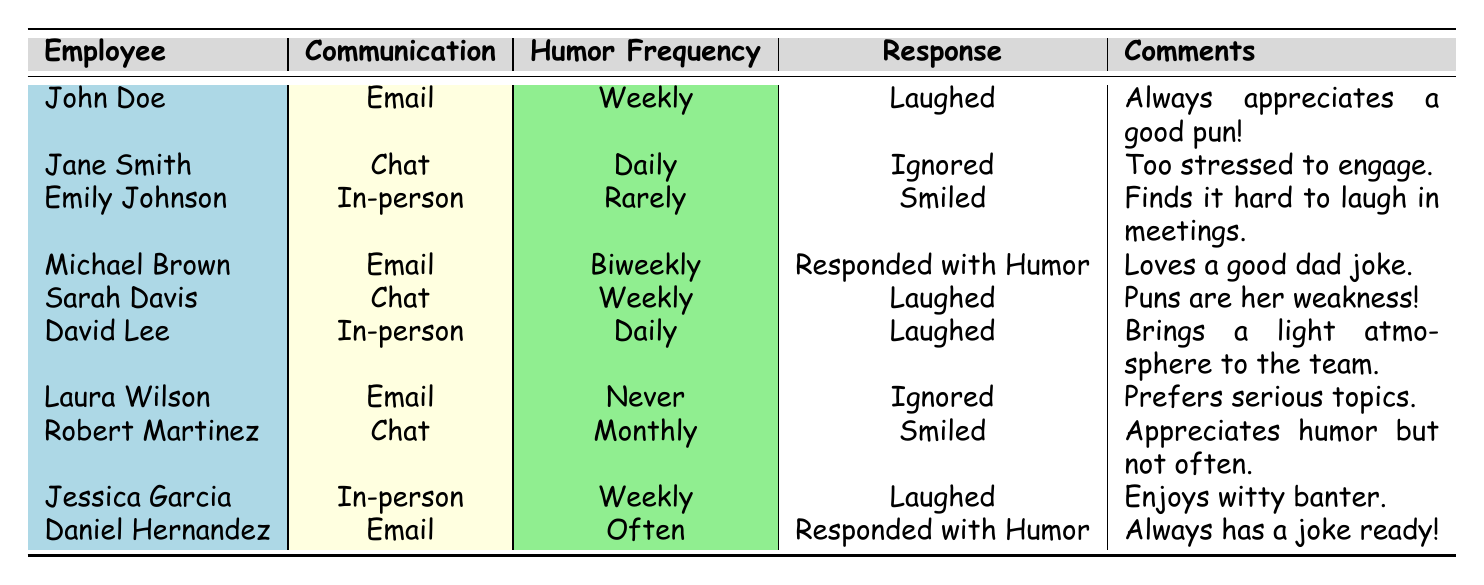What is the response type for John Doe? The table shows that John Doe's response type is "Laughed."
Answer: Laughed How many employees have a humor frequency of "Daily"? There are two employees with a humor frequency of "Daily": Jane Smith and David Lee.
Answer: 2 Which communication type received the most "Laughed" responses? Looking at the response types, "Chat" (Sarah Davis) and "In-person" (David Lee, Jessica Garcia) each received laughs. However, "In-person" has two employees responding this way making it more frequent.
Answer: In-person Is Laura Wilson's humor frequency ever? According to the table, Laura Wilson has a humor frequency of "Never."
Answer: Yes What is the average humor frequency among the in-person communication types? The in-person frequencies are "Rarely," "Daily," and "Weekly," which can be graded as follows: Rarely=1, Daily=2, Weekly=3. Their sum is 1+2+3 = 6. Dividing by 3 (the number of entries) gives us an average of 2.
Answer: 2 How many employees responded with humor at least once? The employees who responded with humor are John Doe, Michael Brown, Daniel Hernandez, and Jessica Garcia. This counts up to a total of four.
Answer: 4 Which employee prefers serious topics and never engages in humorous communications? The employee that prefers serious topics, as indicated by "Never" in humor frequency, is Laura Wilson.
Answer: Laura Wilson What percentage of the employees laughed at the humor communications? There are 10 employees total, and 5 employees laughed (John Doe, David Lee, Sarah Davis, Jessica Garcia). Thus, the percentage is (5/10)*100 = 50%.
Answer: 50% 